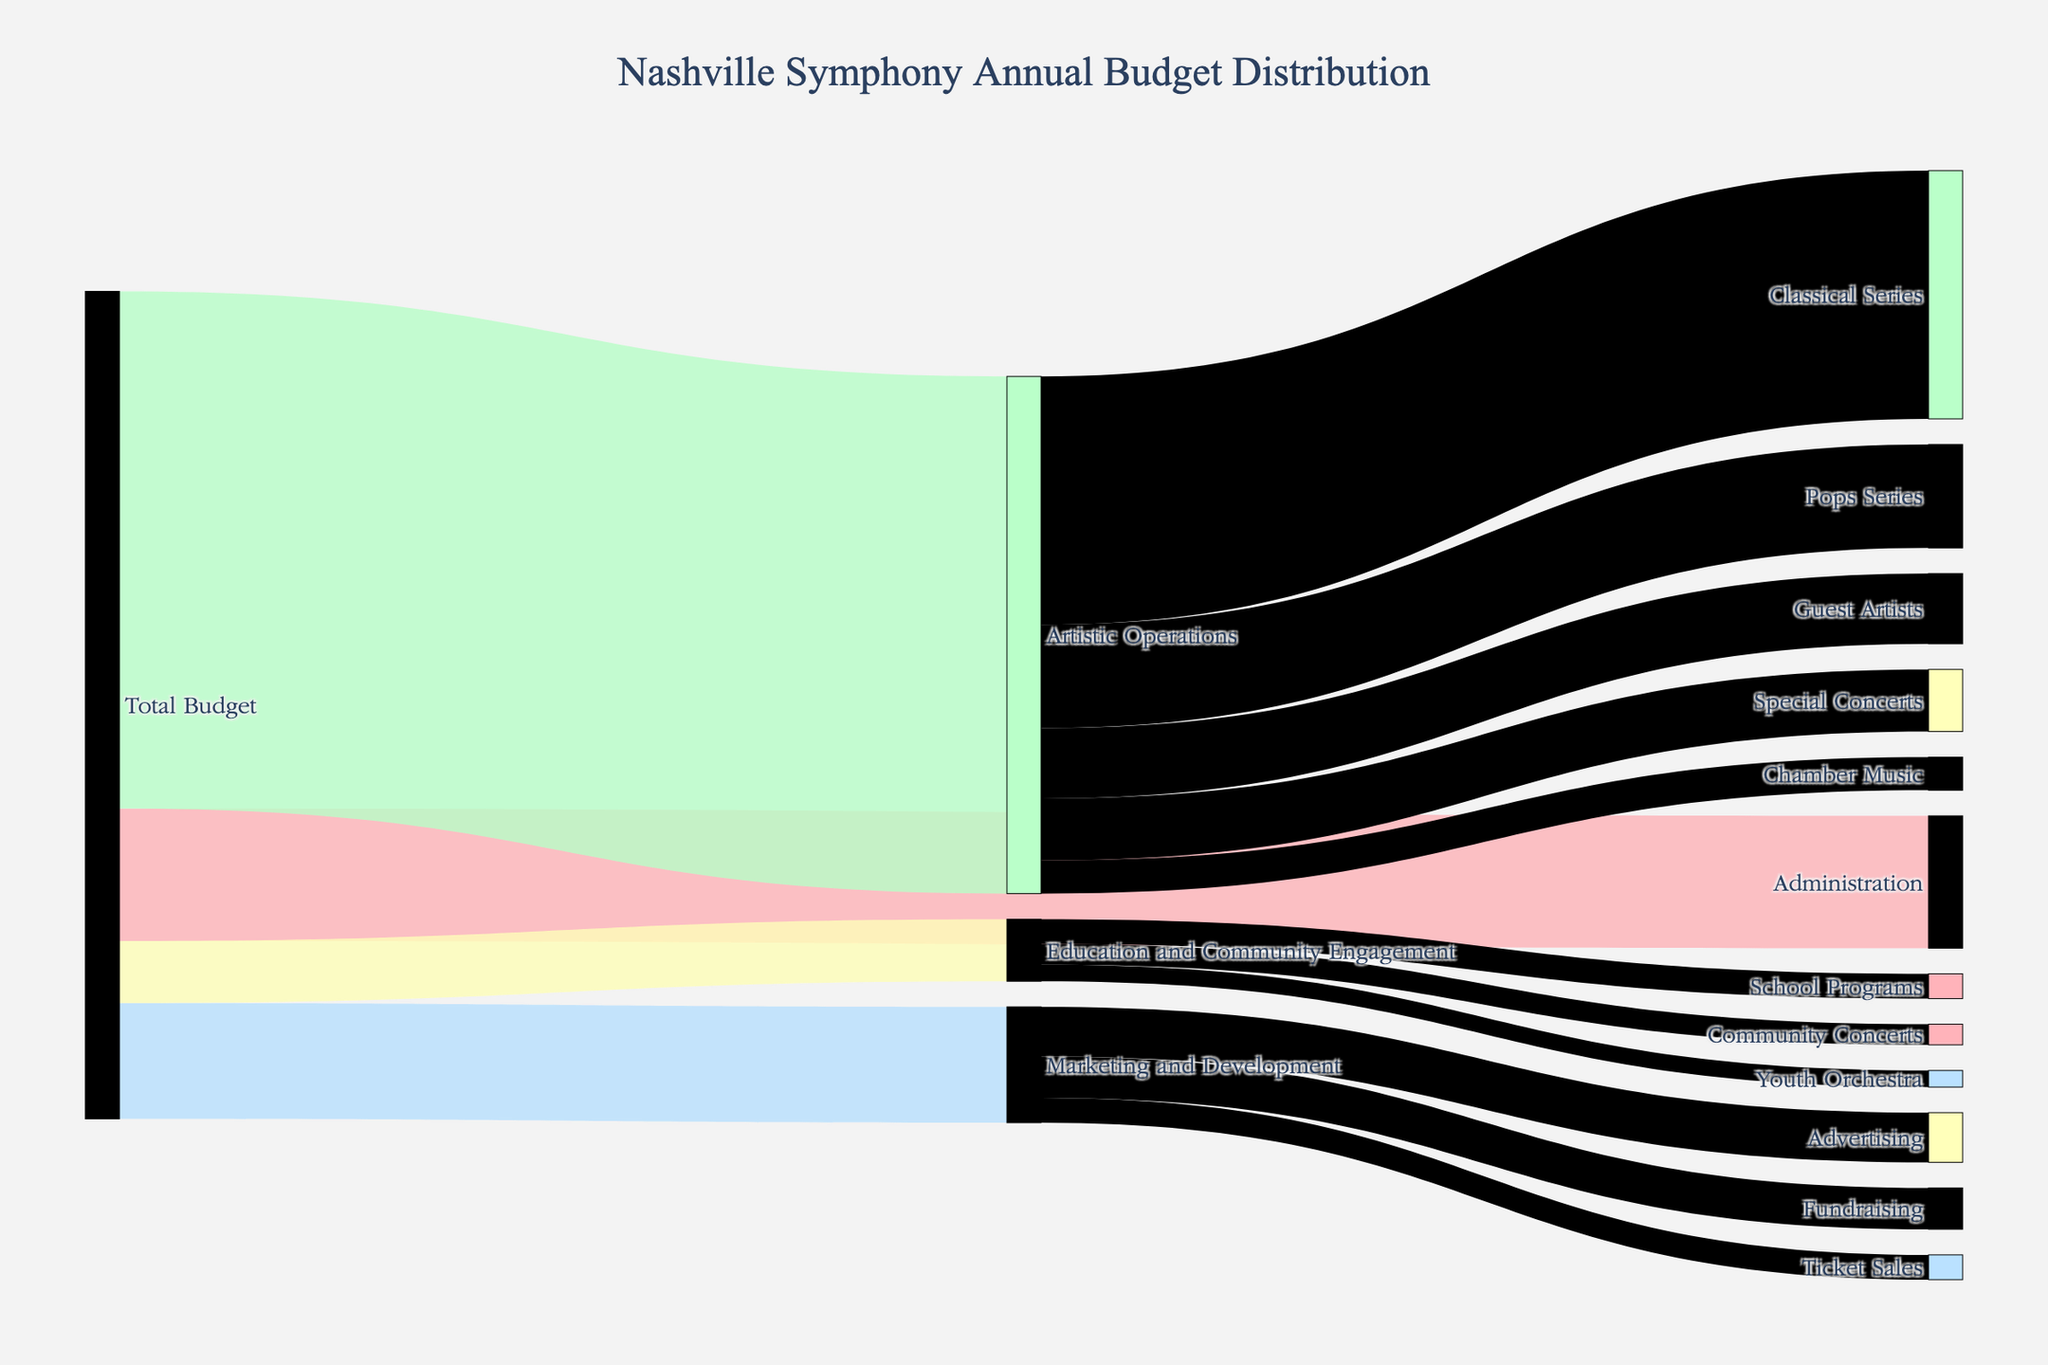What is the title of the figure? The title of the figure is usually displayed at the top and signifies what the figure represents.
Answer: "Nashville Symphony Annual Budget Distribution" How many departments are shown in the diagram? By observing the targets connected directly to "Total Budget," we can count the departments.
Answer: 4 What is the color of the link between "Total Budget" and "Administration"? Each link has a specific color in the diagram, representing the flow to the departments.
Answer: Light pink What is the total budget allocated to "Artistic Operations" and "Marketing and Development" combined? Sum the values directed to "Artistic Operations" ($12,500,000) and "Marketing and Development" ($2,800,000).
Answer: $15,300,000 What's the average budget allocated to the different performance types under "Artistic Operations"? Add the budgets of Classical Series, Pops Series, Special Concerts, Chamber Music, and Guest Artists, then divide by 5. Calculation: (6,000,000 + 2,500,000 + 1,500,000 + 800,000 + 1,700,000) / 5 = 12,500,000 / 5
Answer: $2,500,000 Which receives a higher budget: "Youth Orchestra" or "School Programs"? Compare the values directed to "Youth Orchestra" (400,000) and "School Programs" (600,000).
Answer: School Programs Is the budget for "Guest Artists" greater than the combined budget for "Community Concerts" and "Ticket Sales"? First, sum the budgets for "Community Concerts" ($500,000) and "Ticket Sales" ($600,000), then compare with "Guest Artists" ($1,700,000). $500,000 + $600,000 = $1,100,000
Answer: Yes What is the proportion of the total budget allocated to "Education and Community Engagement"? To find the percentage, we take the budget for "Education and Community Engagement" and divide it by the total budget, then multiply by 100. Calculation: ($1,500,000 / $20,000,000) * 100
Answer: 7.5% Which performance type under "Artistic Operations" has the smallest budget? By comparing the values of the performance types under "Artistic Operations" (Classical Series, Pops Series, Special Concerts, Chamber Music, Guest Artists), identify the smallest one.
Answer: Chamber Music 